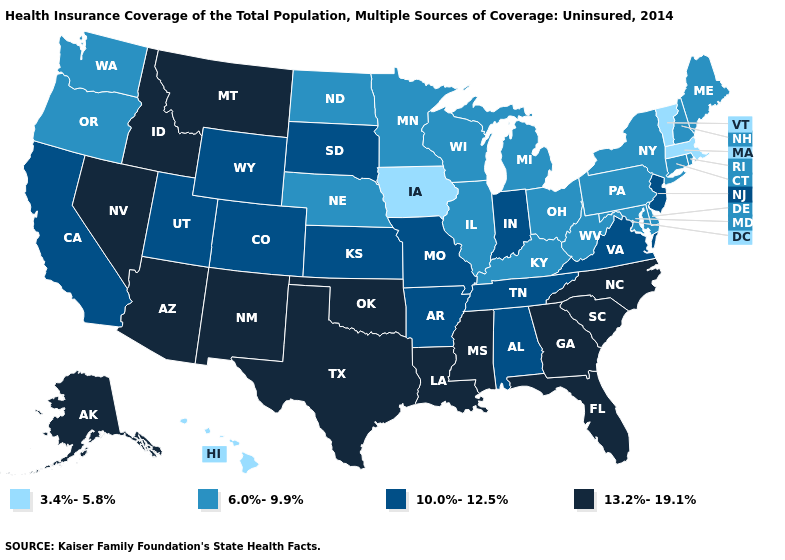Does Washington have the highest value in the West?
Answer briefly. No. Which states have the highest value in the USA?
Concise answer only. Alaska, Arizona, Florida, Georgia, Idaho, Louisiana, Mississippi, Montana, Nevada, New Mexico, North Carolina, Oklahoma, South Carolina, Texas. Which states have the lowest value in the West?
Keep it brief. Hawaii. Among the states that border Iowa , which have the lowest value?
Write a very short answer. Illinois, Minnesota, Nebraska, Wisconsin. Name the states that have a value in the range 6.0%-9.9%?
Concise answer only. Connecticut, Delaware, Illinois, Kentucky, Maine, Maryland, Michigan, Minnesota, Nebraska, New Hampshire, New York, North Dakota, Ohio, Oregon, Pennsylvania, Rhode Island, Washington, West Virginia, Wisconsin. What is the highest value in states that border California?
Answer briefly. 13.2%-19.1%. Name the states that have a value in the range 6.0%-9.9%?
Short answer required. Connecticut, Delaware, Illinois, Kentucky, Maine, Maryland, Michigan, Minnesota, Nebraska, New Hampshire, New York, North Dakota, Ohio, Oregon, Pennsylvania, Rhode Island, Washington, West Virginia, Wisconsin. Is the legend a continuous bar?
Keep it brief. No. Among the states that border Montana , which have the highest value?
Keep it brief. Idaho. Which states hav the highest value in the Northeast?
Concise answer only. New Jersey. Does the map have missing data?
Answer briefly. No. Which states have the lowest value in the South?
Short answer required. Delaware, Kentucky, Maryland, West Virginia. Among the states that border Illinois , does Kentucky have the highest value?
Concise answer only. No. Does Washington have the lowest value in the West?
Be succinct. No. Among the states that border Utah , which have the lowest value?
Answer briefly. Colorado, Wyoming. 